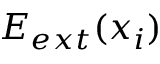Convert formula to latex. <formula><loc_0><loc_0><loc_500><loc_500>E _ { e x t } ( x _ { i } )</formula> 